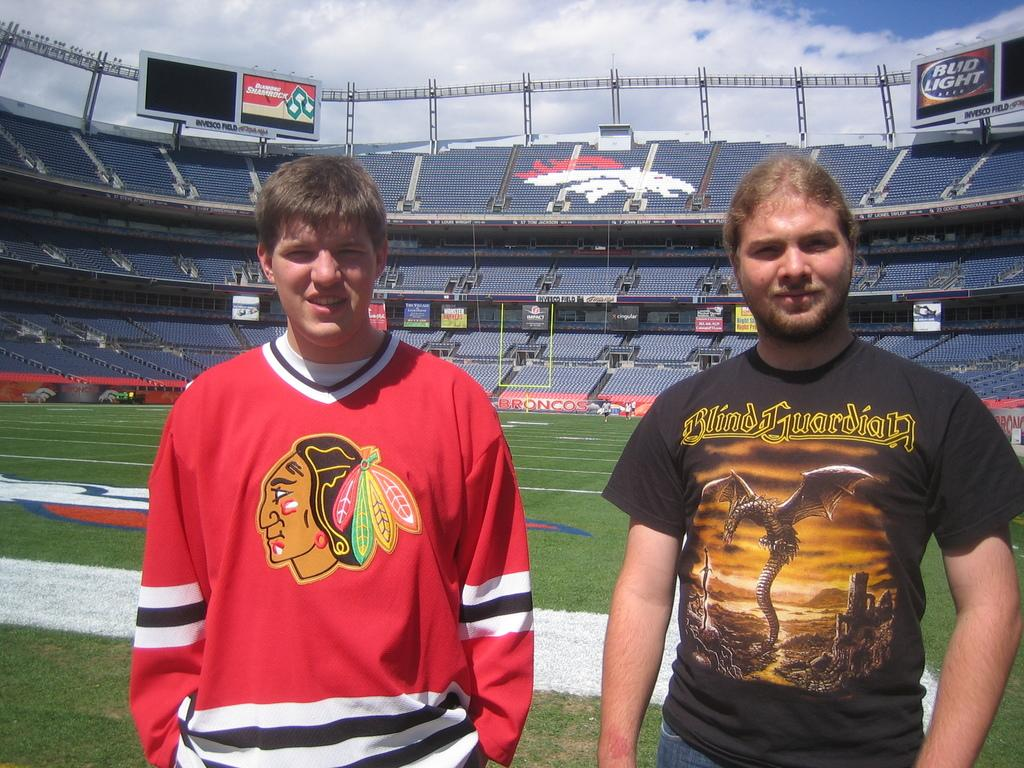<image>
Render a clear and concise summary of the photo. A boy wearing a Blackhawks jersey stands on the Denver Broncos field. 